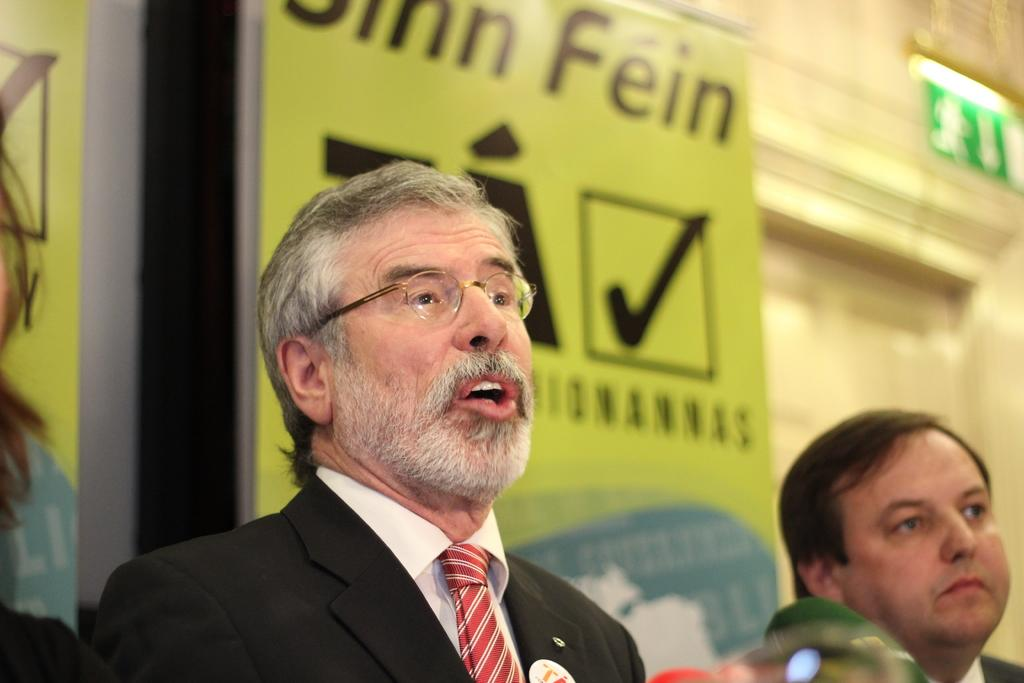Who or what is present in the image? There are people in the image. What else can be seen in the image besides the people? There are advertising boards in the image. Where is the door located in the image? The door is on the right side of the image. What type of organization is depicted on the advertising boards in the image? There is no specific organization mentioned or depicted on the advertising boards in the image. 